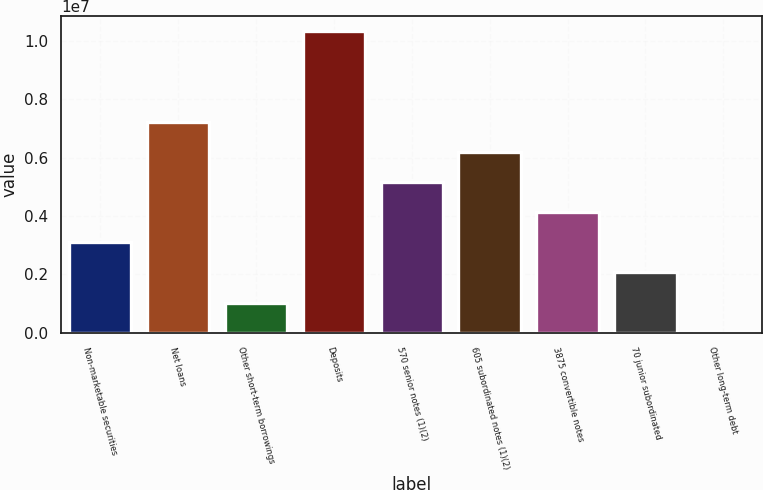<chart> <loc_0><loc_0><loc_500><loc_500><bar_chart><fcel>Non-marketable securities<fcel>Net loans<fcel>Other short-term borrowings<fcel>Deposits<fcel>570 senior notes (1)(2)<fcel>605 subordinated notes (1)(2)<fcel>3875 convertible notes<fcel>70 junior subordinated<fcel>Other long-term debt<nl><fcel>3.10472e+06<fcel>7.23456e+06<fcel>1.0398e+06<fcel>1.03319e+07<fcel>5.16964e+06<fcel>6.2021e+06<fcel>4.13718e+06<fcel>2.07226e+06<fcel>7339<nl></chart> 